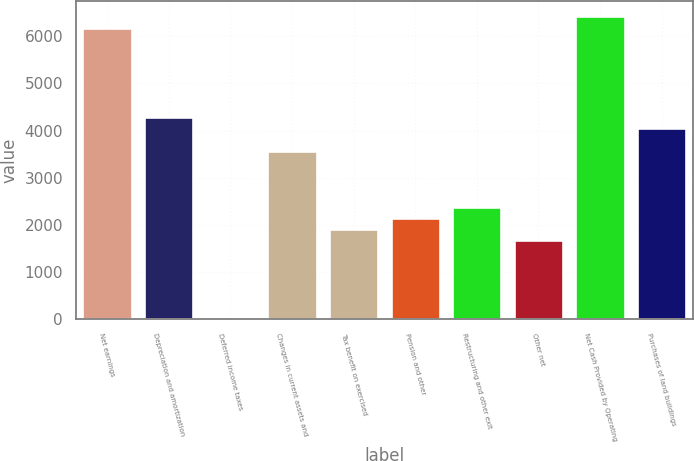<chart> <loc_0><loc_0><loc_500><loc_500><bar_chart><fcel>Net earnings<fcel>Depreciation and amortization<fcel>Deferred income taxes<fcel>Changes in current assets and<fcel>Tax benefit on exercised<fcel>Pension and other<fcel>Restructuring and other exit<fcel>Other net<fcel>Net Cash Provided by Operating<fcel>Purchases of land buildings<nl><fcel>6186.6<fcel>4285.8<fcel>9<fcel>3573<fcel>1909.8<fcel>2147.4<fcel>2385<fcel>1672.2<fcel>6424.2<fcel>4048.2<nl></chart> 